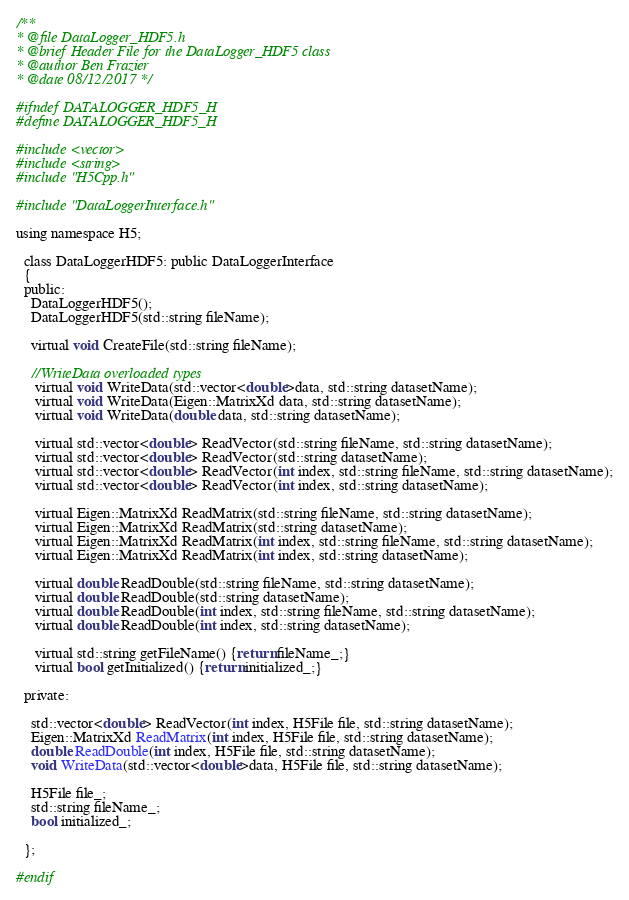Convert code to text. <code><loc_0><loc_0><loc_500><loc_500><_C_>/**
* @file DataLogger_HDF5.h
* @brief Header File for the DataLogger_HDF5 class
* @author Ben Frazier
* @date 08/12/2017 */

#ifndef DATALOGGER_HDF5_H
#define DATALOGGER_HDF5_H

#include <vector>
#include <string>
#include "H5Cpp.h"

#include "DataLoggerInterface.h"

using namespace H5;

  class DataLoggerHDF5: public DataLoggerInterface
  {
  public:
    DataLoggerHDF5();
    DataLoggerHDF5(std::string fileName);
    
    virtual void CreateFile(std::string fileName);

    //WriteData overloaded types
     virtual void WriteData(std::vector<double>data, std::string datasetName);
     virtual void WriteData(Eigen::MatrixXd data, std::string datasetName);
     virtual void WriteData(double data, std::string datasetName);
    
     virtual std::vector<double> ReadVector(std::string fileName, std::string datasetName);
     virtual std::vector<double> ReadVector(std::string datasetName);
     virtual std::vector<double> ReadVector(int index, std::string fileName, std::string datasetName);
     virtual std::vector<double> ReadVector(int index, std::string datasetName);
    
     virtual Eigen::MatrixXd ReadMatrix(std::string fileName, std::string datasetName);
     virtual Eigen::MatrixXd ReadMatrix(std::string datasetName);
     virtual Eigen::MatrixXd ReadMatrix(int index, std::string fileName, std::string datasetName);
     virtual Eigen::MatrixXd ReadMatrix(int index, std::string datasetName);
     
     virtual double ReadDouble(std::string fileName, std::string datasetName);
     virtual double ReadDouble(std::string datasetName);
     virtual double ReadDouble(int index, std::string fileName, std::string datasetName);
     virtual double ReadDouble(int index, std::string datasetName);
    
     virtual std::string getFileName() {return fileName_;}  
     virtual bool getInitialized() {return initialized_;}

  private:

	std::vector<double> ReadVector(int index, H5File file, std::string datasetName);
	Eigen::MatrixXd ReadMatrix(int index, H5File file, std::string datasetName);
	double ReadDouble(int index, H5File file, std::string datasetName);
	void WriteData(std::vector<double>data, H5File file, std::string datasetName);
	
    H5File file_;
    std::string fileName_;
    bool initialized_;

  };

#endif
</code> 